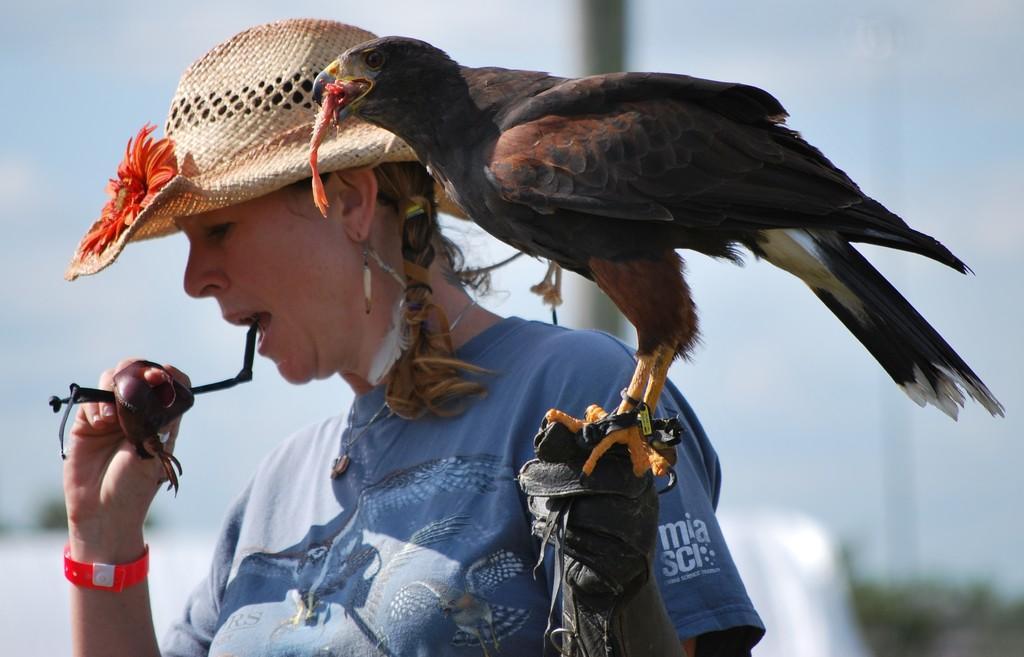How would you summarize this image in a sentence or two? In this image, I can see a woman holding an insect and a bird, which is holding food. There is a blurred background. 